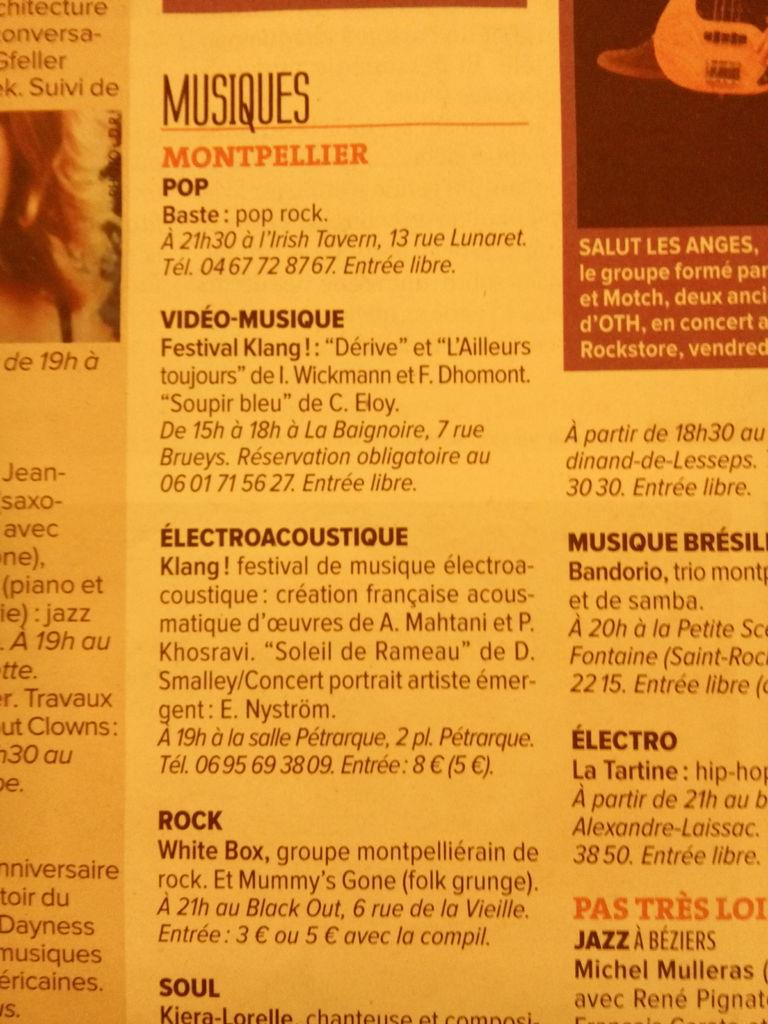What is present on the paper in the image? The paper contains numbers, words, and photos. Can you describe the content of the paper in more detail? The paper contains numbers, which are likely used for calculations or organization, words, which may convey information or instructions, and photos, which could be used for illustration or reference. How does the ladybug stop on the paper in the image? There is no ladybug present in the image, so it cannot stop on the paper. 